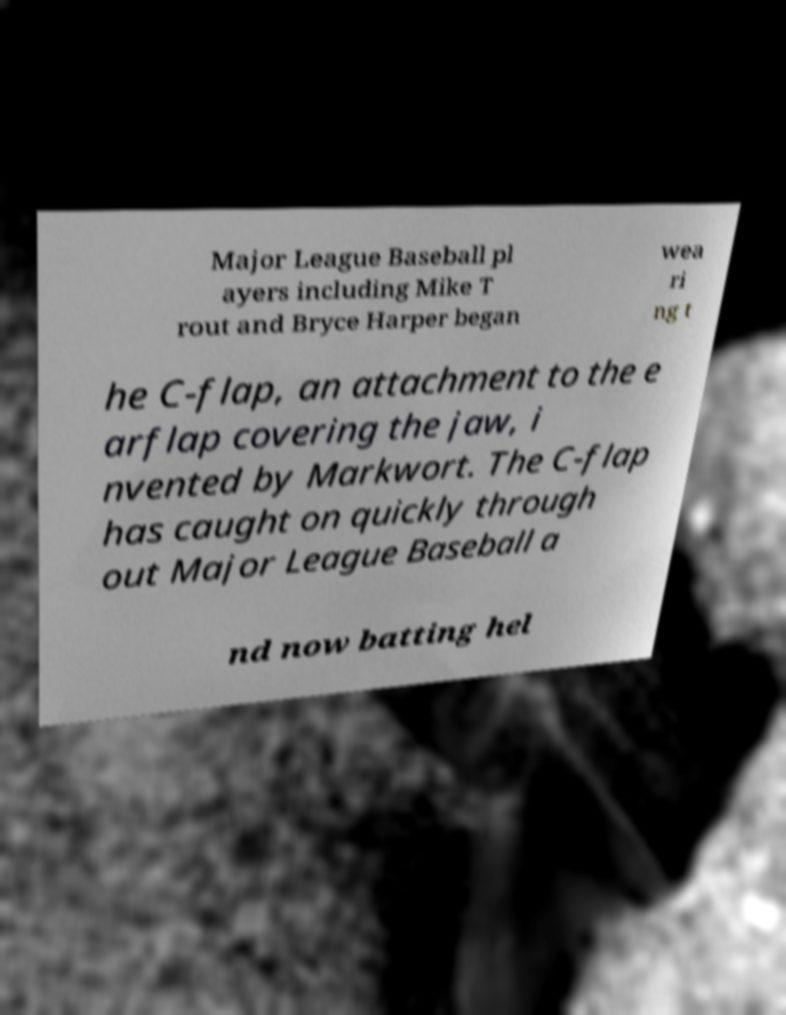I need the written content from this picture converted into text. Can you do that? Major League Baseball pl ayers including Mike T rout and Bryce Harper began wea ri ng t he C-flap, an attachment to the e arflap covering the jaw, i nvented by Markwort. The C-flap has caught on quickly through out Major League Baseball a nd now batting hel 